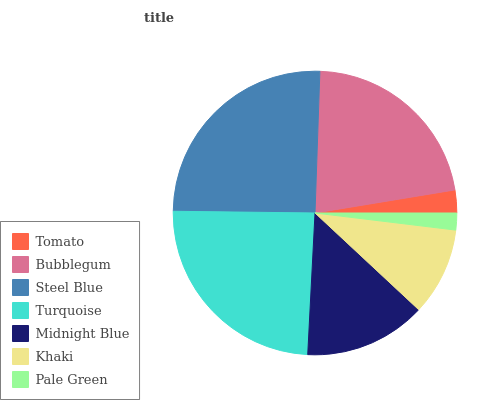Is Pale Green the minimum?
Answer yes or no. Yes. Is Steel Blue the maximum?
Answer yes or no. Yes. Is Bubblegum the minimum?
Answer yes or no. No. Is Bubblegum the maximum?
Answer yes or no. No. Is Bubblegum greater than Tomato?
Answer yes or no. Yes. Is Tomato less than Bubblegum?
Answer yes or no. Yes. Is Tomato greater than Bubblegum?
Answer yes or no. No. Is Bubblegum less than Tomato?
Answer yes or no. No. Is Midnight Blue the high median?
Answer yes or no. Yes. Is Midnight Blue the low median?
Answer yes or no. Yes. Is Tomato the high median?
Answer yes or no. No. Is Khaki the low median?
Answer yes or no. No. 